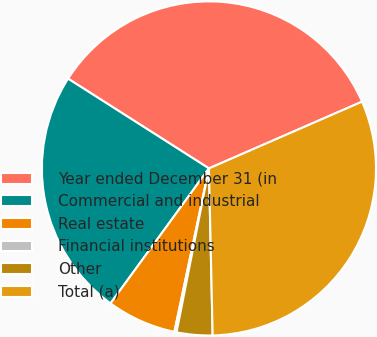<chart> <loc_0><loc_0><loc_500><loc_500><pie_chart><fcel>Year ended December 31 (in<fcel>Commercial and industrial<fcel>Real estate<fcel>Financial institutions<fcel>Other<fcel>Total (a)<nl><fcel>34.43%<fcel>24.0%<fcel>6.71%<fcel>0.21%<fcel>3.46%<fcel>31.19%<nl></chart> 